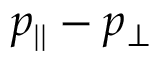<formula> <loc_0><loc_0><loc_500><loc_500>p _ { | | } - p _ { \perp }</formula> 